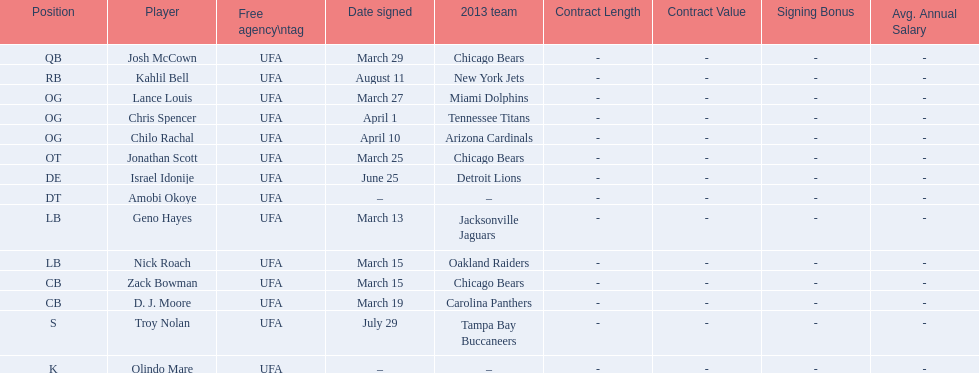Signed the same date as "april fools day". Chris Spencer. 